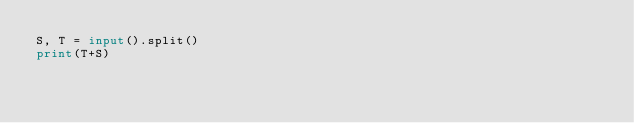<code> <loc_0><loc_0><loc_500><loc_500><_Python_>S, T = input().split()
print(T+S)
</code> 